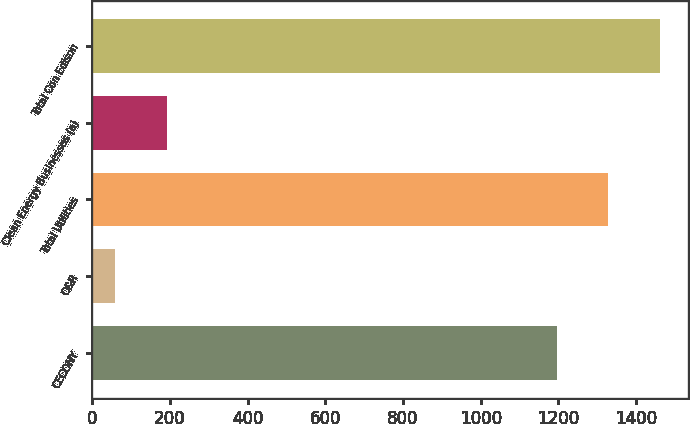Convert chart to OTSL. <chart><loc_0><loc_0><loc_500><loc_500><bar_chart><fcel>CECONY<fcel>O&R<fcel>Total Utilities<fcel>Clean Energy Businesses (a)<fcel>Total Con Edison<nl><fcel>1196<fcel>59<fcel>1328.3<fcel>191.3<fcel>1460.6<nl></chart> 